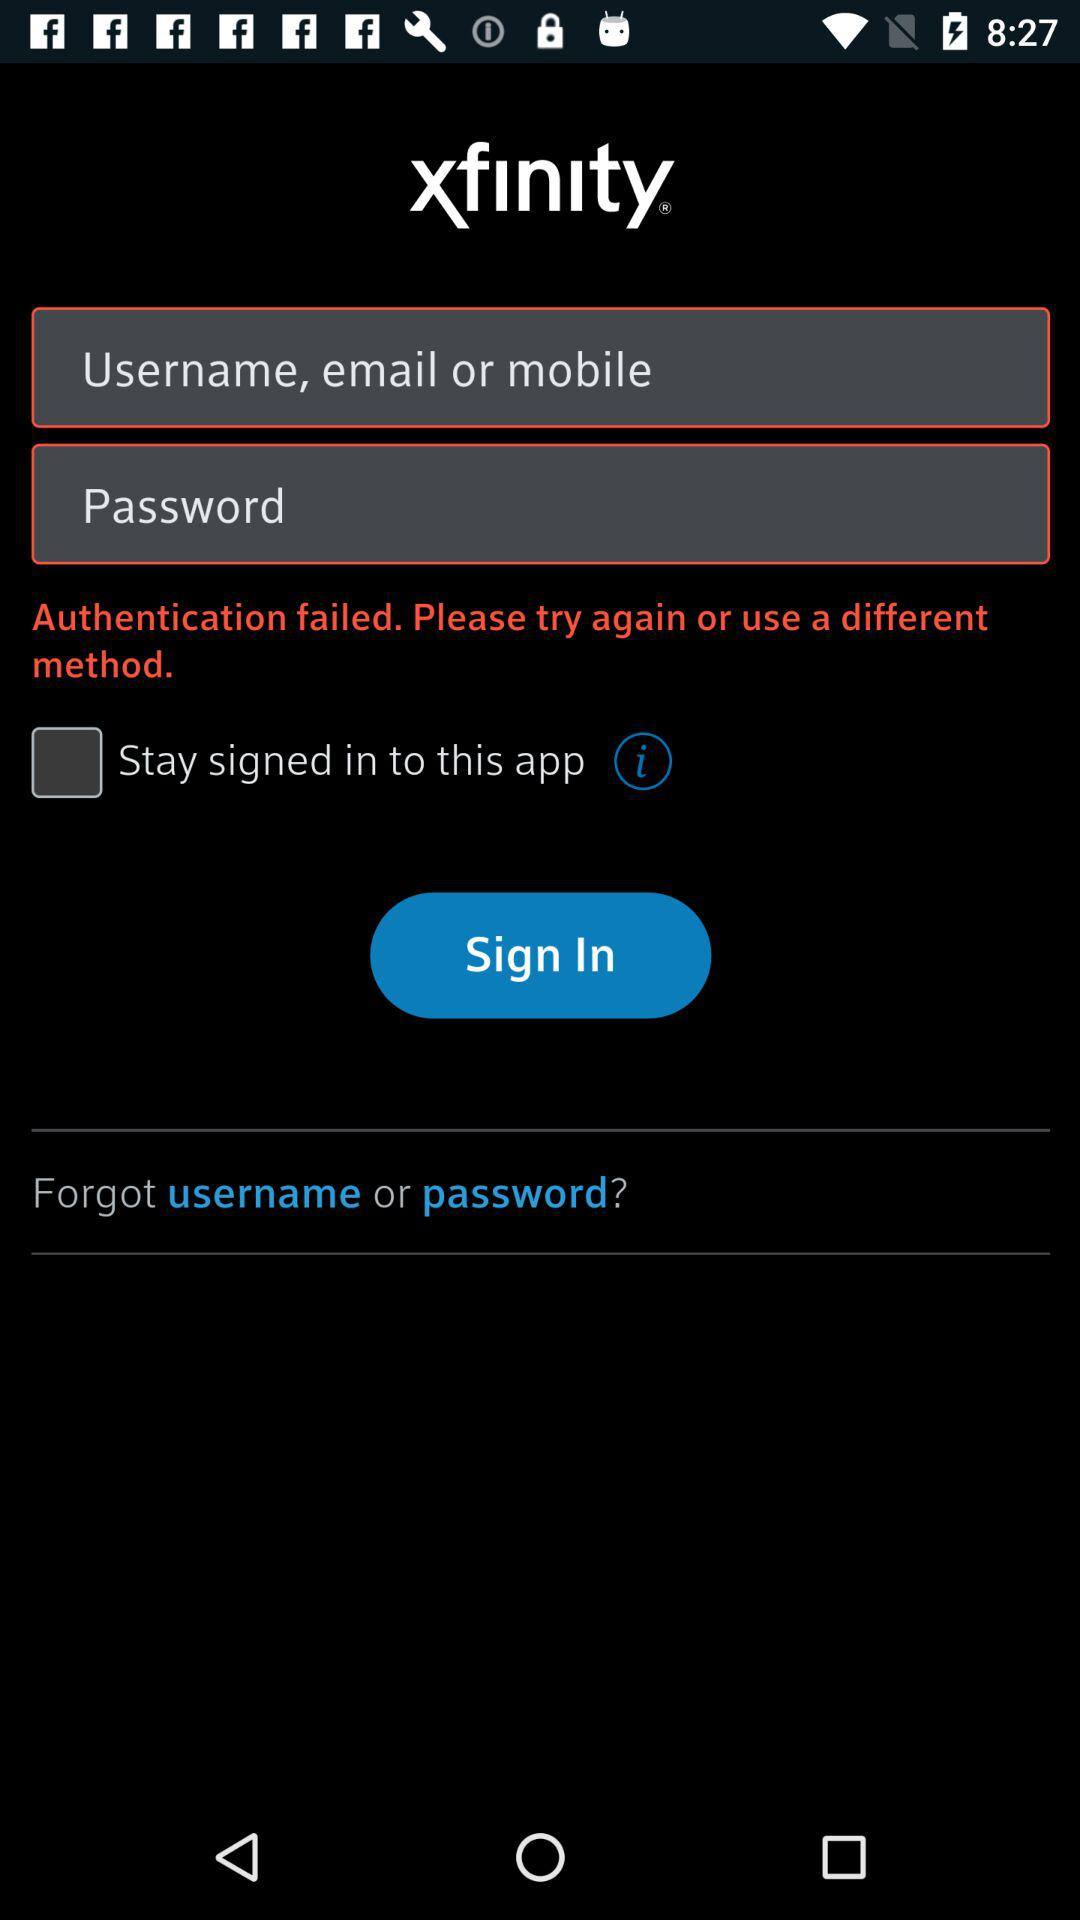What are the requirements to get a sign-in? The requirements are "Username, email or mobile" and "Password". 